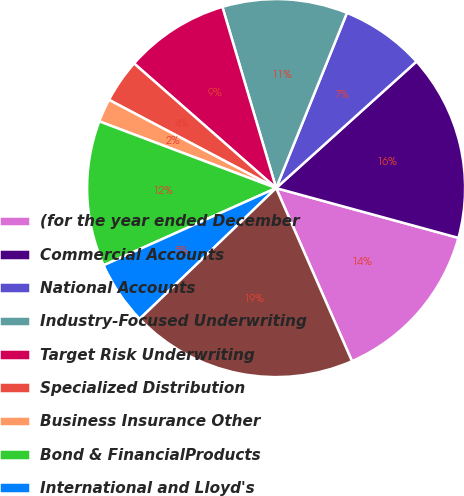<chart> <loc_0><loc_0><loc_500><loc_500><pie_chart><fcel>(for the year ended December<fcel>Commercial Accounts<fcel>National Accounts<fcel>Industry-Focused Underwriting<fcel>Target Risk Underwriting<fcel>Specialized Distribution<fcel>Business Insurance Other<fcel>Bond & FinancialProducts<fcel>International and Lloyd's<fcel>Total Financial Professional &<nl><fcel>14.18%<fcel>15.92%<fcel>7.21%<fcel>10.7%<fcel>8.95%<fcel>3.73%<fcel>1.99%<fcel>12.44%<fcel>5.47%<fcel>19.41%<nl></chart> 